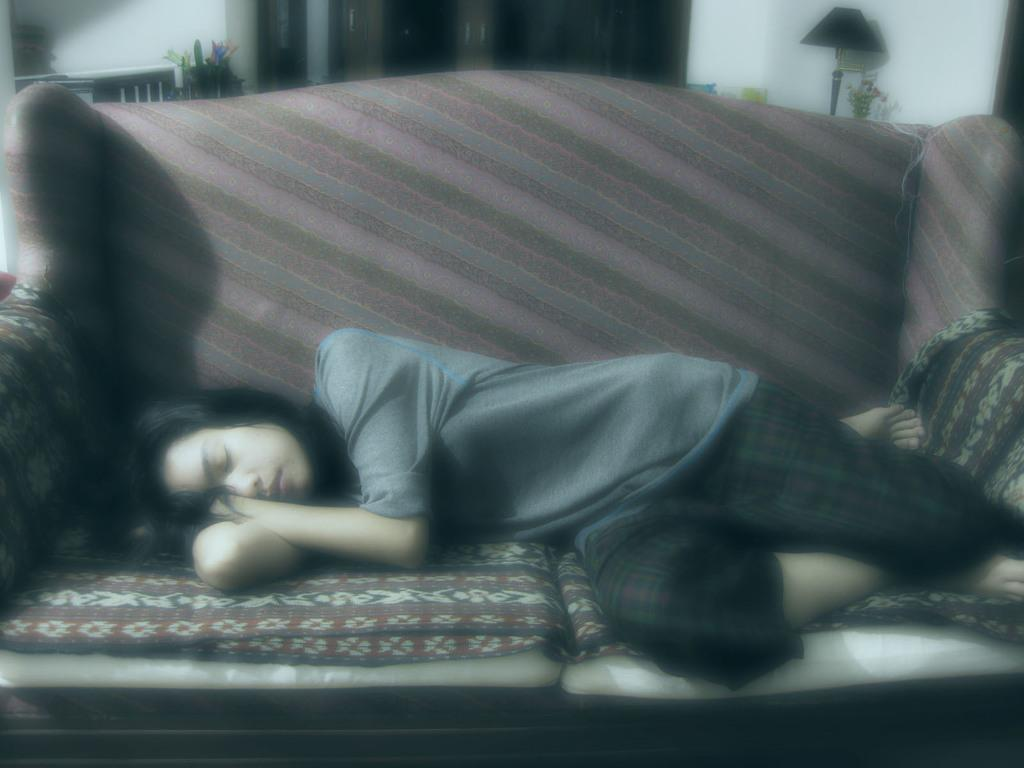What is the woman doing in the image? The woman is lying on the sofa in the image. What can be seen in the background of the image? There is a light lamp, plants, and a wall in the background of the image. Can you describe the lighting in the image? The image is blurred, which may affect the clarity of the light lamp. What type of cactus is on the woman's lap in the image? There is no cactus present in the image; the woman is lying on the sofa without any visible plants or objects on her lap. 